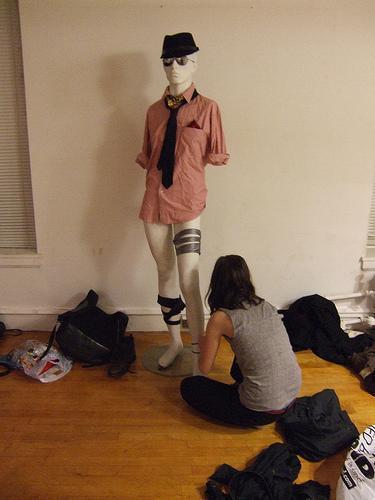How many people are in the photo?
Give a very brief answer. 1. 